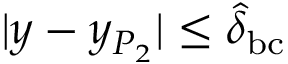<formula> <loc_0><loc_0><loc_500><loc_500>| y - y _ { P _ { 2 } } | \leq \hat { \delta } _ { b c }</formula> 